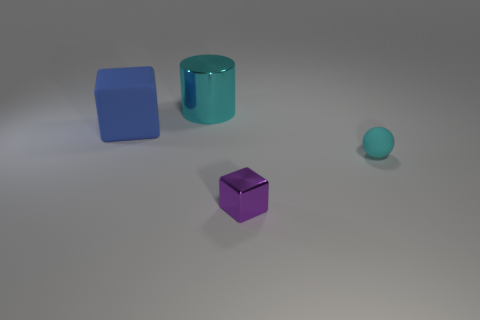Add 1 metal objects. How many objects exist? 5 Subtract 1 spheres. How many spheres are left? 0 Subtract all red cylinders. Subtract all cyan cubes. How many cylinders are left? 1 Subtract all blue spheres. How many yellow cylinders are left? 0 Subtract all small purple metal blocks. Subtract all tiny cyan matte balls. How many objects are left? 2 Add 2 small cyan things. How many small cyan things are left? 3 Add 2 cubes. How many cubes exist? 4 Subtract 0 brown cylinders. How many objects are left? 4 Subtract all balls. How many objects are left? 3 